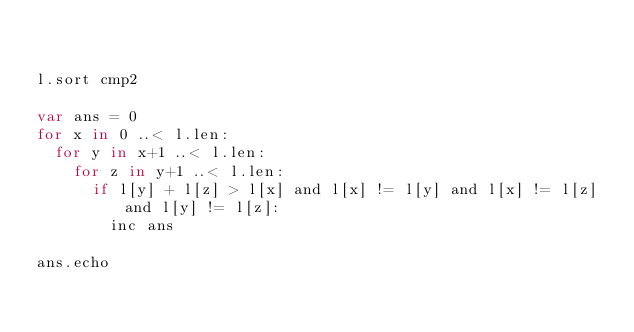Convert code to text. <code><loc_0><loc_0><loc_500><loc_500><_Nim_>

l.sort cmp2

var ans = 0
for x in 0 ..< l.len:
  for y in x+1 ..< l.len:
    for z in y+1 ..< l.len:
      if l[y] + l[z] > l[x] and l[x] != l[y] and l[x] != l[z] and l[y] != l[z]:
        inc ans

ans.echo
</code> 